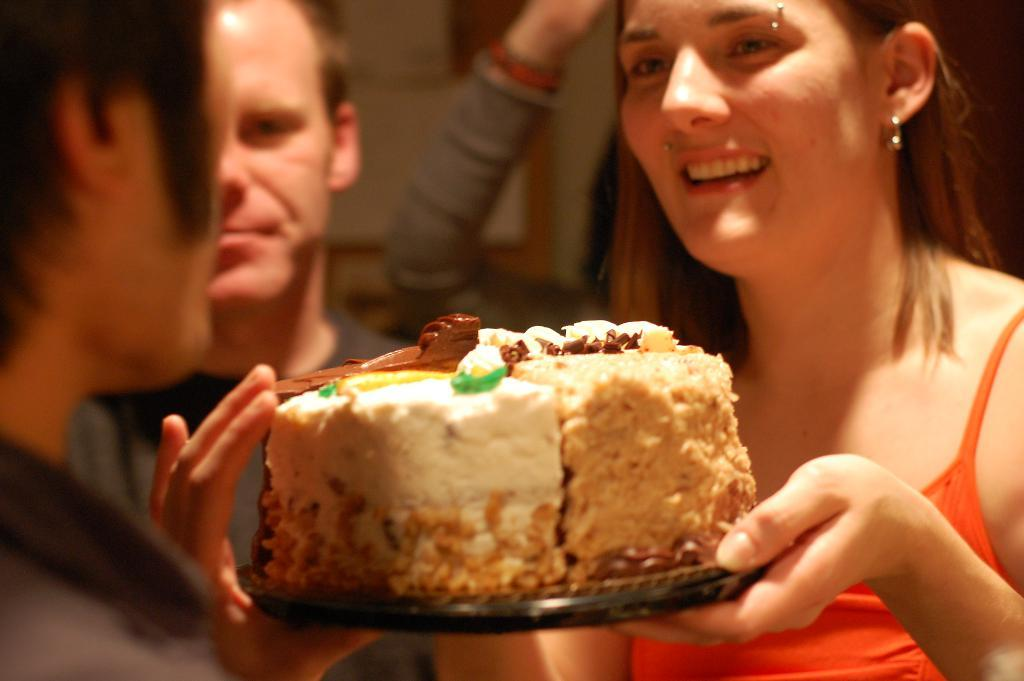What can be seen in the image? There are people in the image. What is the woman holding in her hands? The woman is holding a cake in her hands. Can you describe the background of the image? The background of the image is blurred. What type of meat can be seen hanging from the ceiling in the image? There is no meat or hanging objects present in the image; it features people and a woman holding a cake. 